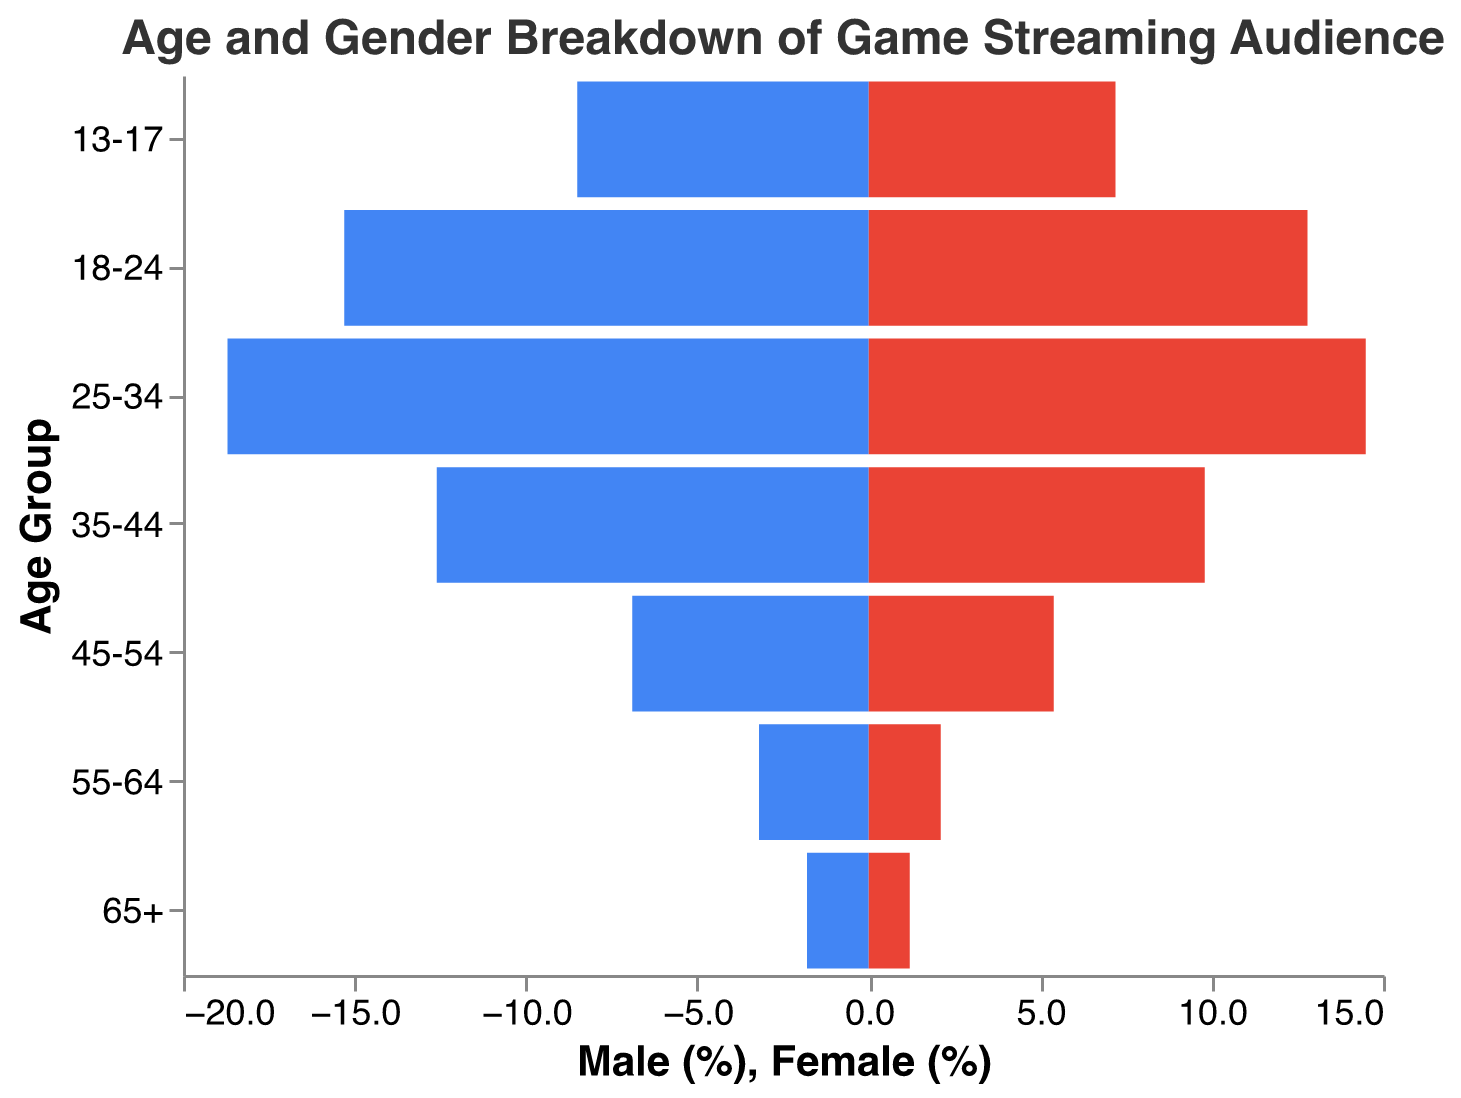What's the title of the chart? The title is meant to succinctly describe the content of the chart. According to the provided code, the title is specified.
Answer: Age and Gender Breakdown of Game Streaming Audience Which age group has the highest percentage of male viewers? To find the highest percentage of male viewers, look at the male percentages across all age groups and find the maximum value.
Answer: 25-34 What's the percentage difference between male and female viewers in the 18-24 age group? The male percentage for the 18-24 age group is 15.3%, and the female percentage is 12.8%. The difference can be found by subtracting the female percentage from the male percentage. 15.3 - 12.8 = 2.5%
Answer: 2.5% How does the percentage of female viewers in the 35-44 age group compare to the percentage of male viewers in the 45-54 age group? The percentage of female viewers in the 35-44 age group is 9.8%, and the percentage of male viewers in the 45-54 age group is 6.9%. Comparing these values shows that 9.8% is greater than 6.9%.
Answer: Female viewers in 35-44 is higher What is the total percentage of game streaming audience in the 55-64 age group? For the 55-64 age group, add the percentages of male and female viewers: 3.2% (male) + 2.1% (female) = 5.3%
Answer: 5.3% Between which two age groups is the gap in male percentage viewership the largest? Calculate the difference in male percentage viewership between consecutive age groups: (13-17 to 18-24: 15.3 - 8.5 = 6.8), (18-24 to 25-34: 18.7 - 15.3 = 3.4), (25-34 to 35-44: 18.7 - 12.6 = 6.1), (35-44 to 45-54: 12.6 - 6.9 = 5.7), (45-54 to 55-64: 6.9 - 3.2 = 3.7), (55-64 to 65+: 3.2 - 1.8 = 1.4). The largest gap is between the 13-17 and 18-24 age groups.
Answer: 13-17 to 18-24 What is the combined percentage of male and female viewers in the 25-34 and 35-44 age groups? Add the male and female percentages for both age groups: (25-34: 18.7% + 14.5%), (35-44: 12.6% + 9.8%). So, 33.2% + 22.4% = 55.6%
Answer: 55.6% Which gender has a higher total percentage across all age groups? Sum the percentages of all age groups for both males and females: Males (8.5 + 15.3 + 18.7 + 12.6 + 6.9 + 3.2 + 1.8 = 67) and Females (7.2 + 12.8 + 14.5 + 9.8 + 5.4 + 2.1 + 1.2 = 53). Comparing these totals shows that males have a higher total percentage.
Answer: Male What is the percentage range for female viewers across all age groups? Find the minimum and maximum percentages for female viewers: min = 1.2% (65+), max = 14.5% (25-34). The range is calculated as 14.5 - 1.2 = 13.3%
Answer: 13.3% 